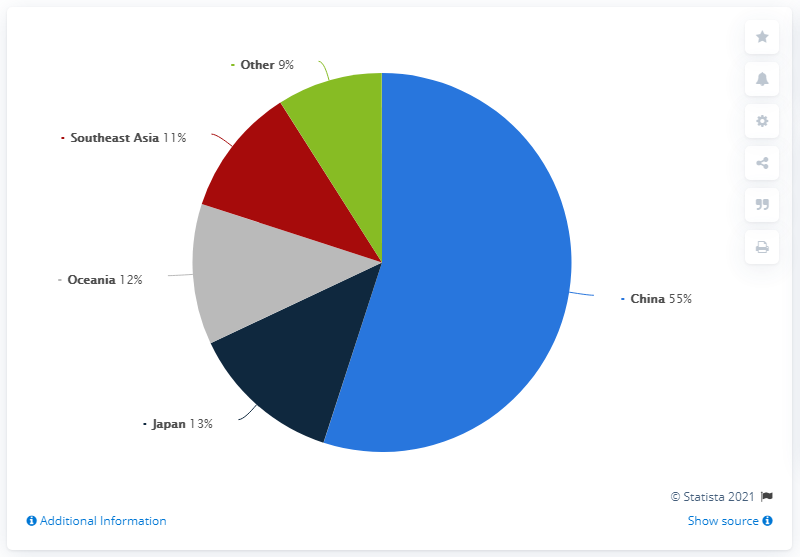What factors might contribute to the comparatively low market share for Southeast Asia? Several factors could contribute to Southeast Asia's lower 11% market share, including economic disparities, competitive markets with diverse options, and possibly lower pricing power. Additionally, the development status and infrastructural constraints in some Southeast Asian countries might impact their market contributions. How could Southeast Asia increase its market share in comparison to other regions? To increase its market share, Southeast Asia could focus on enhancing infrastructure, investing in technology and innovation, improving business environments to attract foreign investments, and fostering competitive industries that can compete on a global scale. 